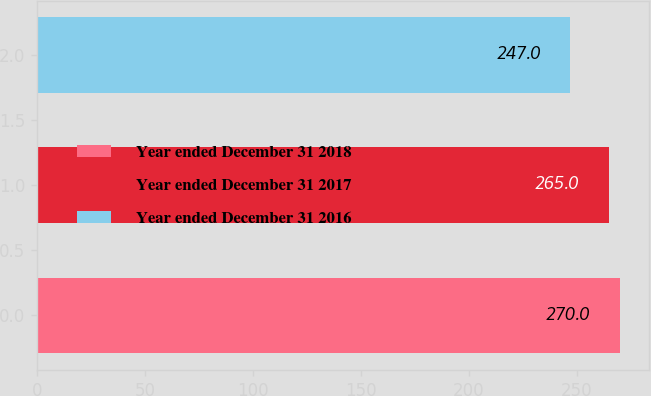<chart> <loc_0><loc_0><loc_500><loc_500><bar_chart><fcel>Year ended December 31 2018<fcel>Year ended December 31 2017<fcel>Year ended December 31 2016<nl><fcel>270<fcel>265<fcel>247<nl></chart> 